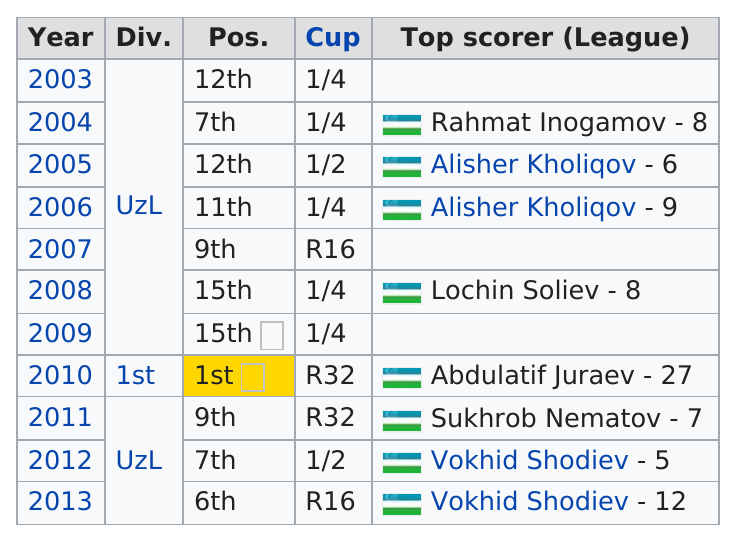Specify some key components in this picture. For how many years was Shodiev the top scorer, with a total of 2? There are five 1/4 cups. The first year listed is 2003. Total times Vokhid Shodiev was the league scorer? 2.." is a question that requires a numerical answer. Alisher Kholiqov is above Lochin Soliev in terms of scoring, with a score of 9. 